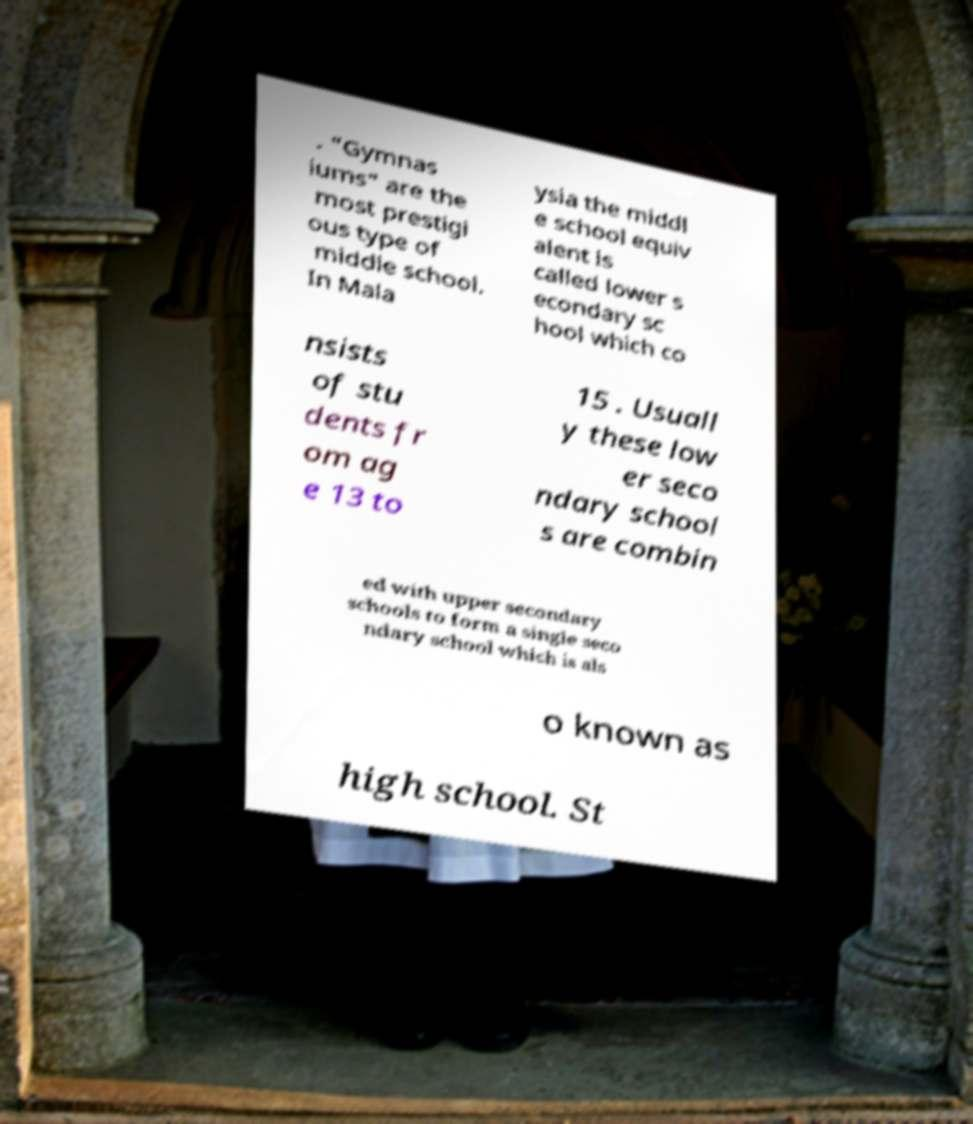What messages or text are displayed in this image? I need them in a readable, typed format. . "Gymnas iums" are the most prestigi ous type of middle school. In Mala ysia the middl e school equiv alent is called lower s econdary sc hool which co nsists of stu dents fr om ag e 13 to 15 . Usuall y these low er seco ndary school s are combin ed with upper secondary schools to form a single seco ndary school which is als o known as high school. St 